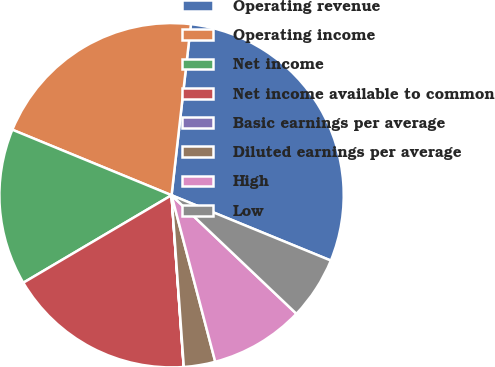Convert chart to OTSL. <chart><loc_0><loc_0><loc_500><loc_500><pie_chart><fcel>Operating revenue<fcel>Operating income<fcel>Net income<fcel>Net income available to common<fcel>Basic earnings per average<fcel>Diluted earnings per average<fcel>High<fcel>Low<nl><fcel>29.4%<fcel>20.58%<fcel>14.7%<fcel>17.64%<fcel>0.01%<fcel>2.95%<fcel>8.83%<fcel>5.89%<nl></chart> 